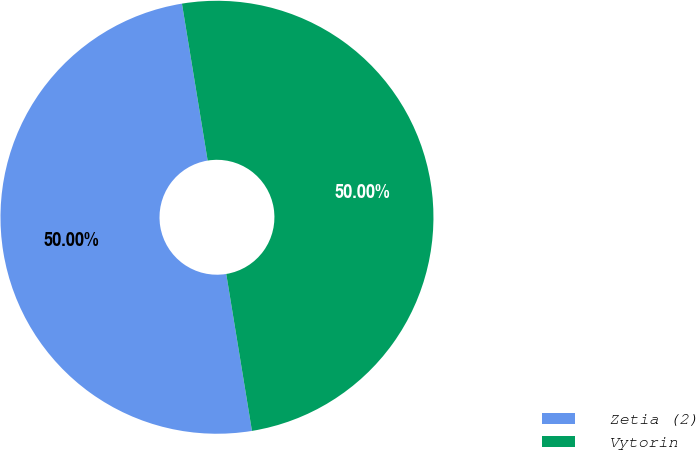<chart> <loc_0><loc_0><loc_500><loc_500><pie_chart><fcel>Zetia (2)<fcel>Vytorin<nl><fcel>50.0%<fcel>50.0%<nl></chart> 